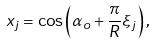<formula> <loc_0><loc_0><loc_500><loc_500>x _ { j } = \cos \left ( \alpha _ { o } + \frac { \pi } { R } \xi _ { j } \right ) ,</formula> 